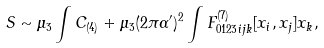Convert formula to latex. <formula><loc_0><loc_0><loc_500><loc_500>S \sim \mu _ { 3 } \int C _ { ( 4 ) } + \mu _ { 3 } ( 2 \pi \alpha ^ { \prime } ) ^ { 2 } \int F _ { 0 1 2 3 i j k } ^ { ( 7 ) } [ x _ { i } , x _ { j } ] x _ { k } ,</formula> 